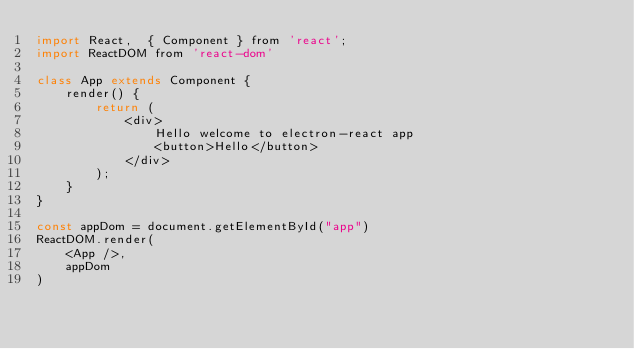<code> <loc_0><loc_0><loc_500><loc_500><_JavaScript_>import React,  { Component } from 'react';
import ReactDOM from 'react-dom'

class App extends Component {
    render() {
        return (
            <div>
                Hello welcome to electron-react app
                <button>Hello</button>
            </div>
        );
    }
}

const appDom = document.getElementById("app")
ReactDOM.render(
    <App />,
    appDom
)
</code> 